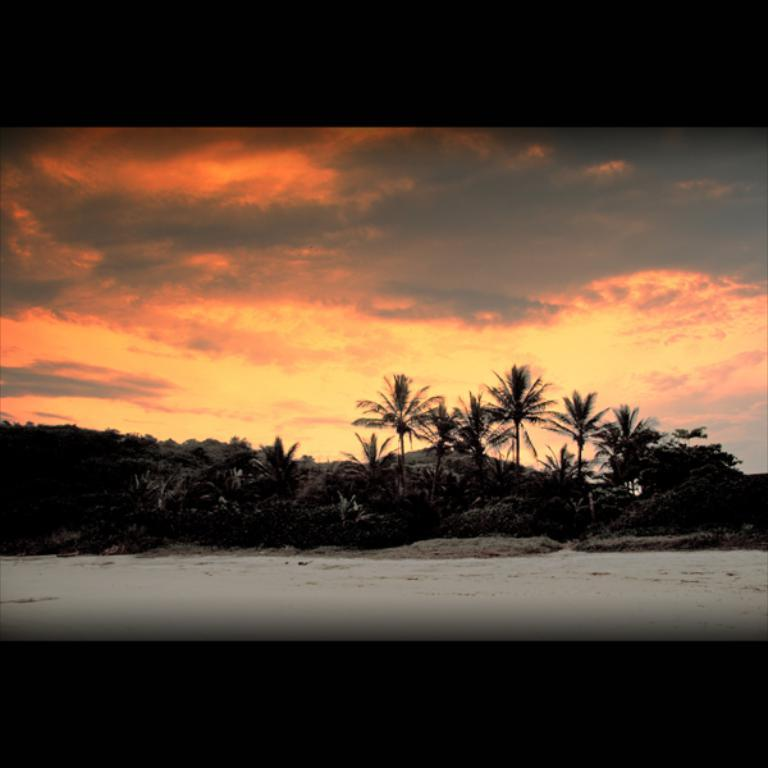What type of vegetation can be seen in the image? There are trees in the image. How would you describe the sky in the image? The sky is cloudy in the image. Despite the cloudy sky, is there any sunlight visible in the image? Yes, sunlight is visible in the image. Can you see any monkeys climbing the trees in the image? There are no monkeys present in the image; it only features trees. Is there a cellar visible in the image? There is no cellar present in the image. 